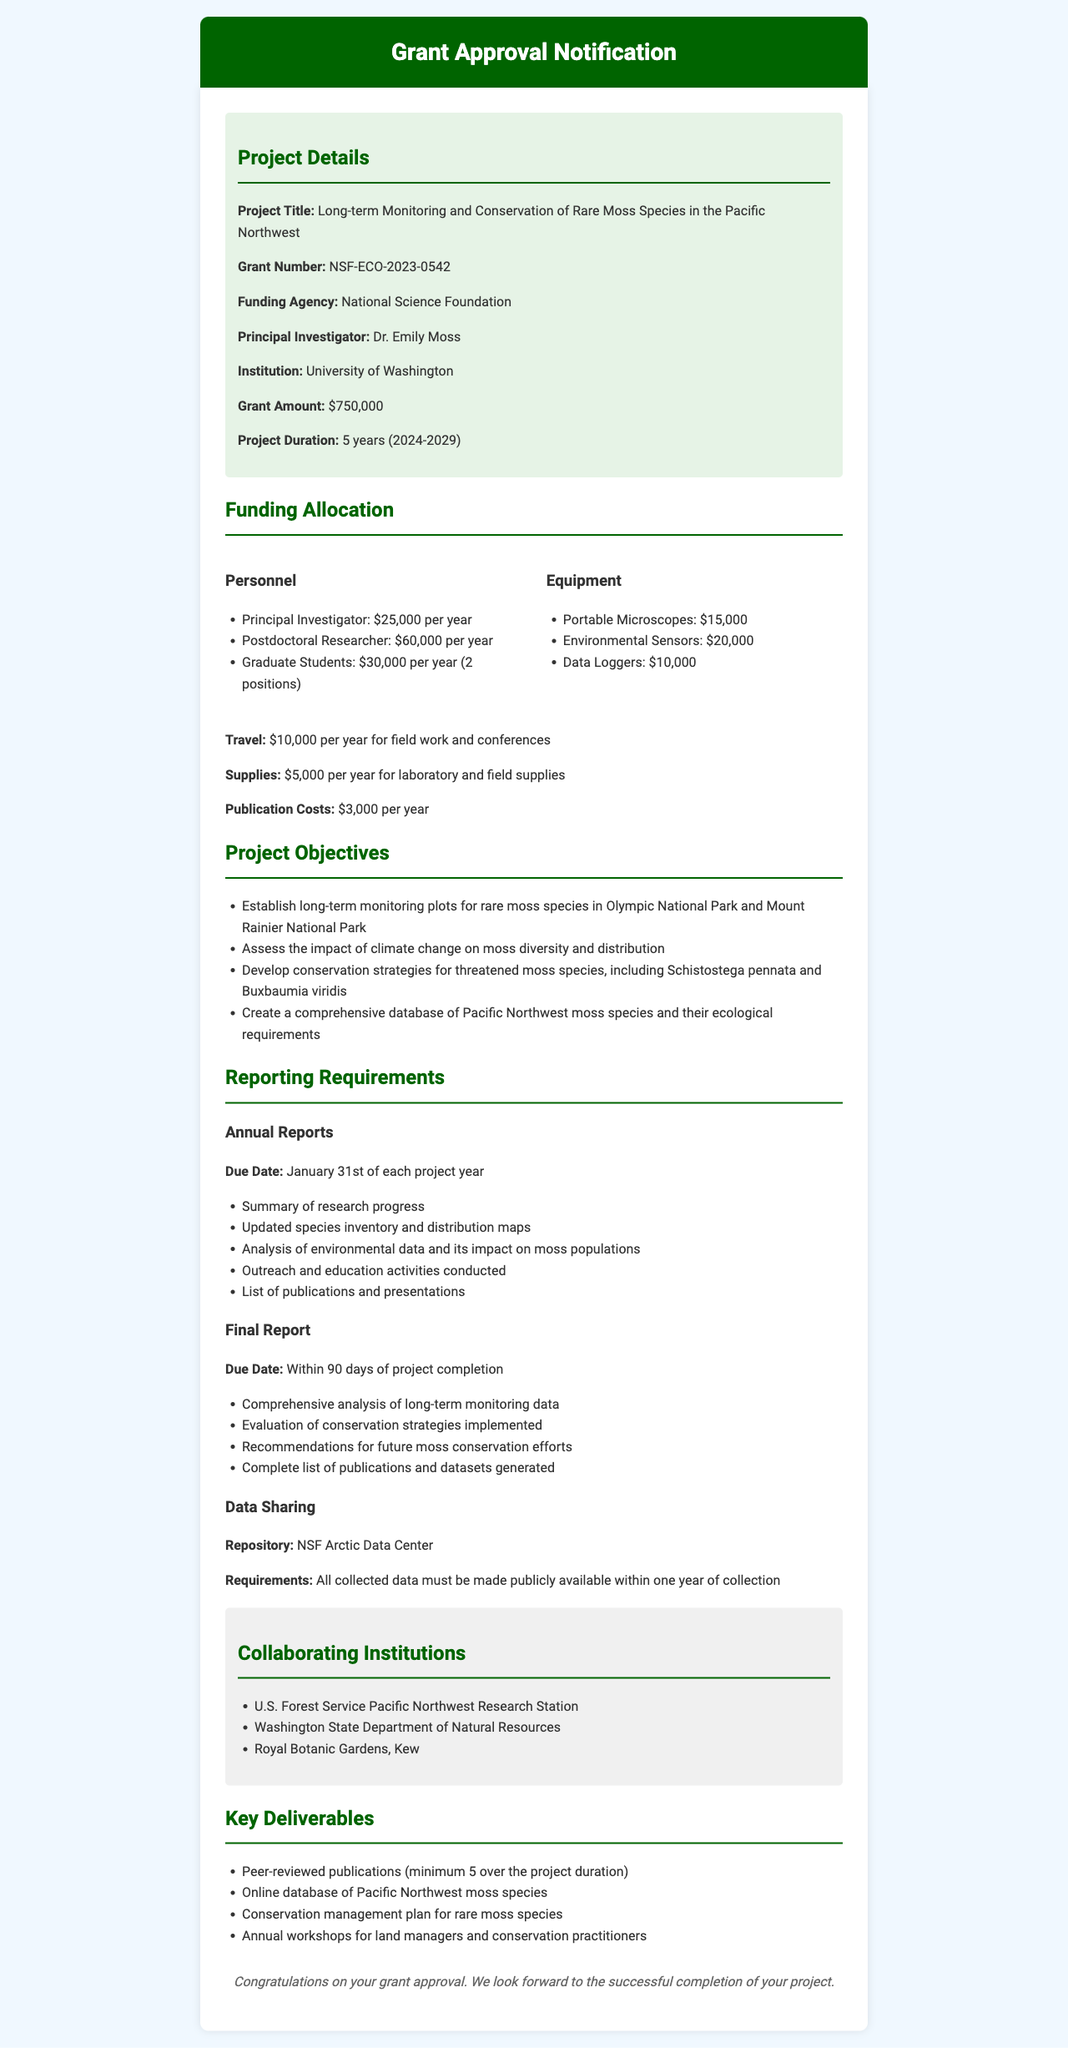What is the project title? The project title is mentioned in the grant details section, which is "Long-term Monitoring and Conservation of Rare Moss Species in the Pacific Northwest."
Answer: Long-term Monitoring and Conservation of Rare Moss Species in the Pacific Northwest What is the total grant amount? The total grant amount is listed in the document under grant details as $750,000.
Answer: $750,000 Who is the principal investigator? The principal investigator's name is provided in the grant details section, which is Dr. Emily Moss.
Answer: Dr. Emily Moss What is the annual due date for reports? The annual report due date is specified in the reporting requirements as January 31st of each project year.
Answer: January 31st How many peer-reviewed publications are required? The document states a minimum of 5 peer-reviewed publications is required over the project duration.
Answer: 5 What is the duration of the project? The project duration is mentioned in the grant details as 5 years, from 2024 to 2029.
Answer: 5 years (2024-2029) Which institution is conducting the project? The institution conducting the project is mentioned in the grant details as the University of Washington.
Answer: University of Washington What is the travel budget per year? The travel budget for field work and conferences is outlined in the funding allocation as $10,000 per year.
Answer: $10,000 per year What is the data sharing repository? The data sharing section specifies that the repository for data sharing is the NSF Arctic Data Center.
Answer: NSF Arctic Data Center 